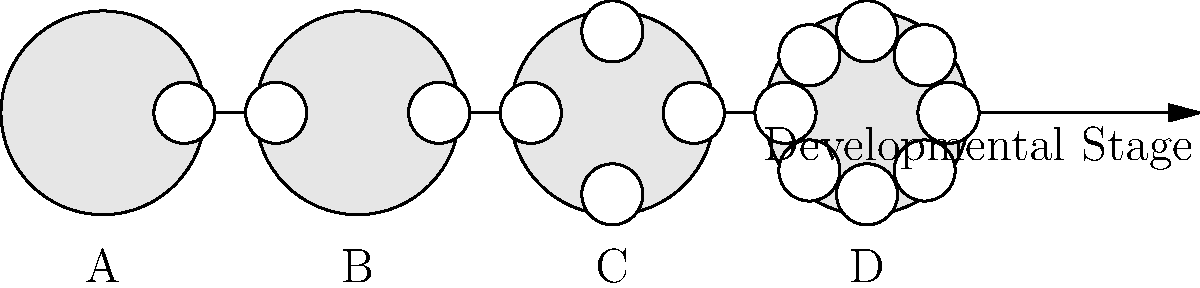Match the embryo images A, B, C, and D to their corresponding developmental stages: zygote, 2-cell, 4-cell, and 8-cell. Which letter represents the 4-cell stage? To answer this question, we need to analyze the images and match them to the developmental stages of an embryo:

1. Image A shows a single large cell, which represents the zygote stage (fertilized egg).
2. Image B displays two distinct cells, indicating the 2-cell stage.
3. Image C clearly shows four separate cells, representing the 4-cell stage.
4. Image D exhibits eight visible cells, corresponding to the 8-cell stage.

The question specifically asks for the letter representing the 4-cell stage. From our analysis, we can see that Image C shows four distinct cells.
Answer: C 